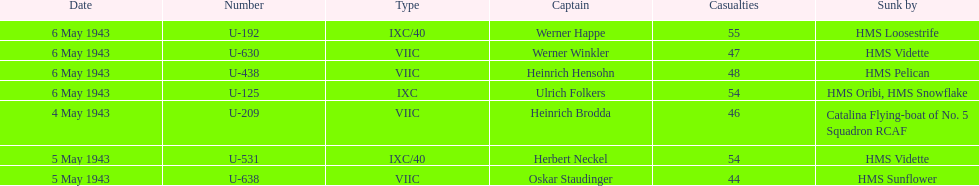Aside from oskar staudinger what was the name of the other captain of the u-boat loast on may 5? Herbert Neckel. 